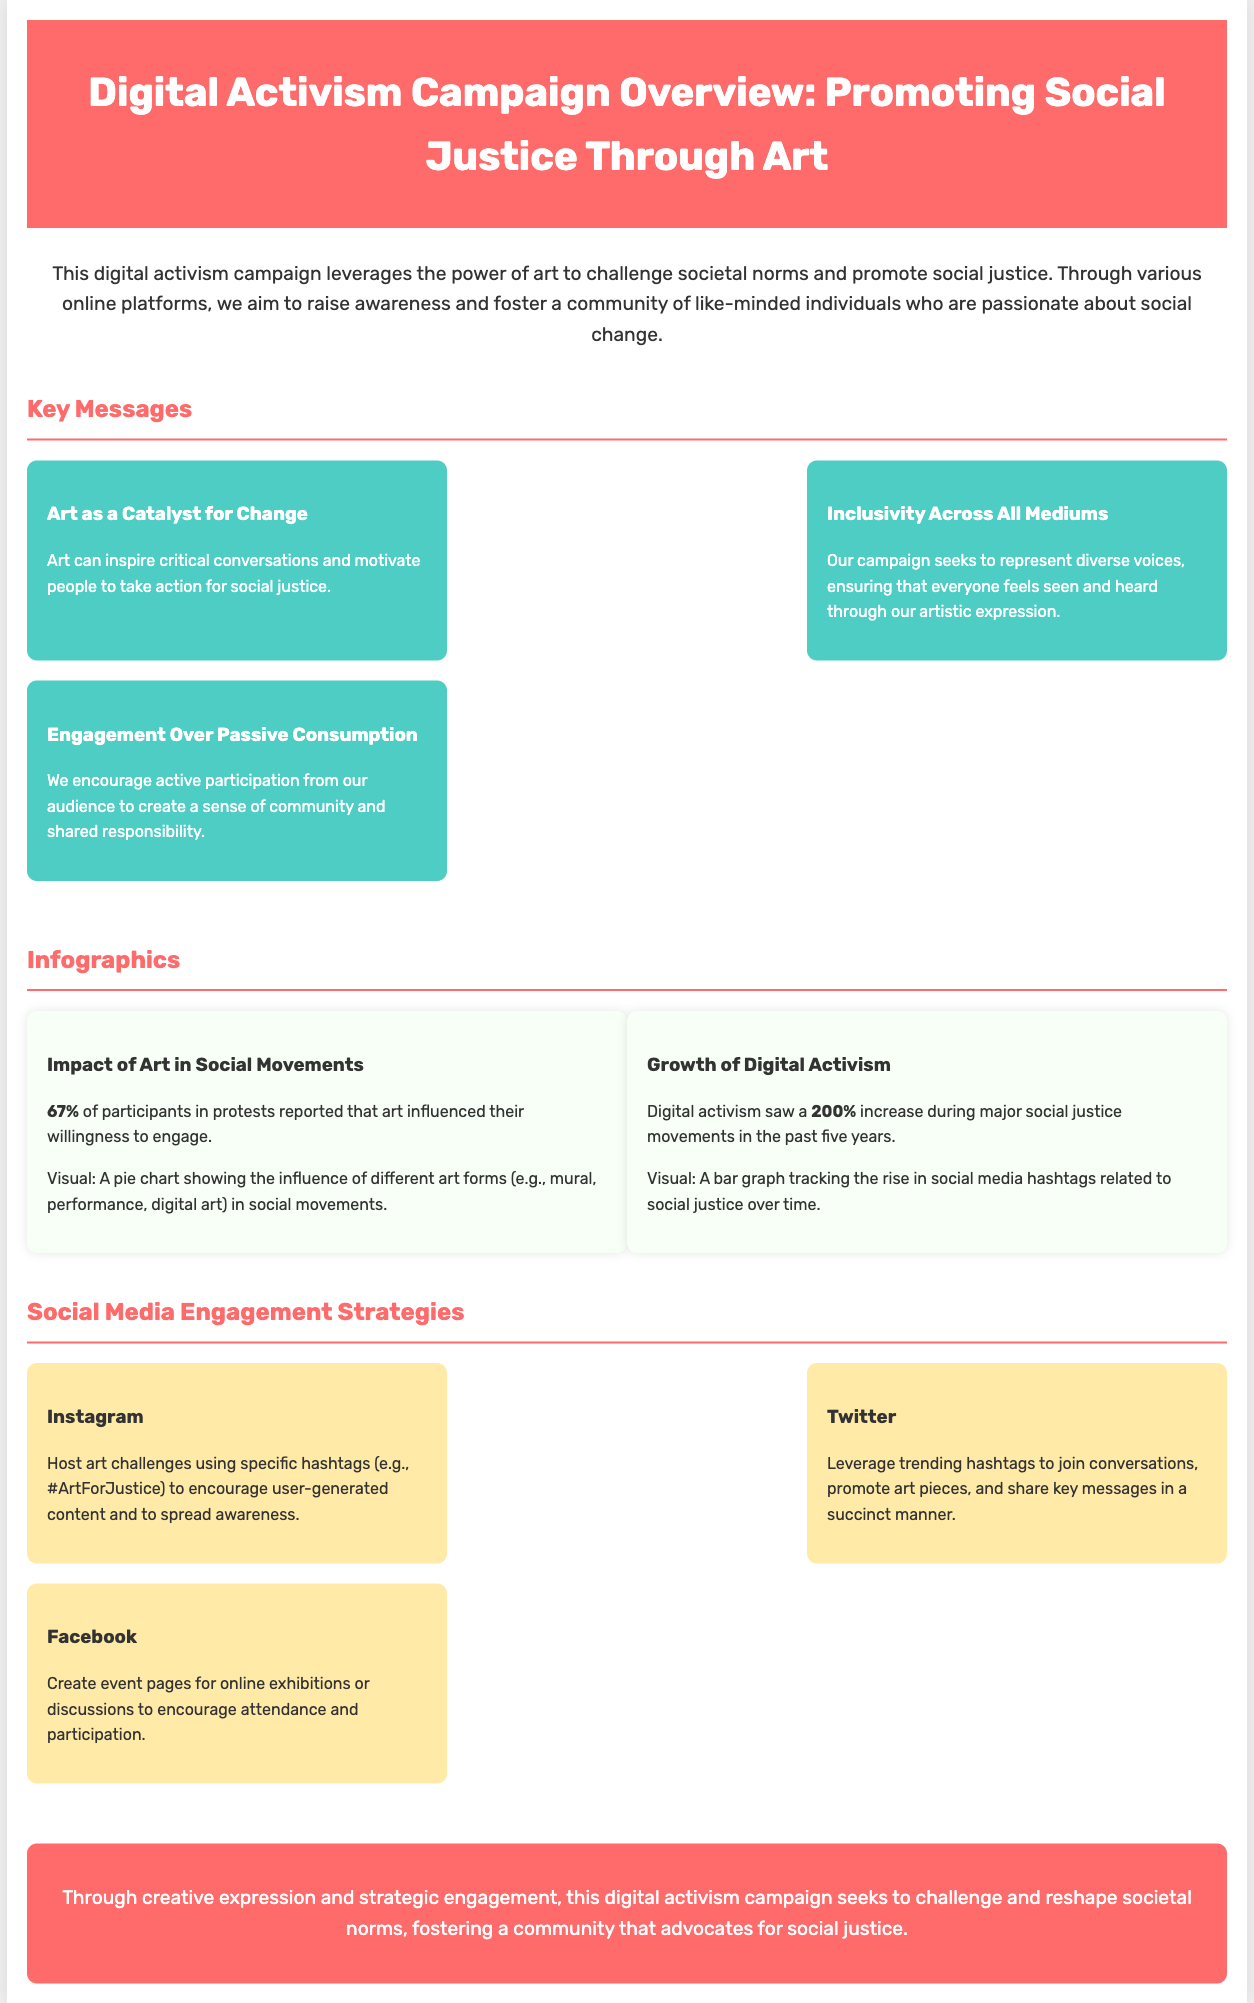What is the main theme of the campaign? The main theme of the campaign is promoting social justice through art.
Answer: promoting social justice through art How many key messages are highlighted in the campaign? The document states three key messages.
Answer: three What is the percentage of participants in protests influenced by art? The infographics indicate that 67% of participants reported this influence.
Answer: 67% Which social media platform is used for hosting art challenges? The document suggests Instagram for hosting art challenges.
Answer: Instagram What increase in digital activism was observed during major movements? The document mentions a 200% increase in digital activism.
Answer: 200% What does the campaign encourage from its audience? The campaign encourages active participation from its audience.
Answer: active participation Which key message emphasizes representation of diverse voices? The key message that emphasizes this is "Inclusivity Across All Mediums."
Answer: Inclusivity Across All Mediums What visual aids are mentioned in the infographics section? The infographics section mentions a pie chart and a bar graph.
Answer: pie chart and bar graph 